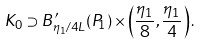<formula> <loc_0><loc_0><loc_500><loc_500>K _ { 0 } \supset B ^ { \prime } _ { \eta _ { 1 } / 4 L } ( P _ { 1 } ) \times \left ( \frac { \eta _ { 1 } } { 8 } , \frac { \eta _ { 1 } } { 4 } \right ) .</formula> 